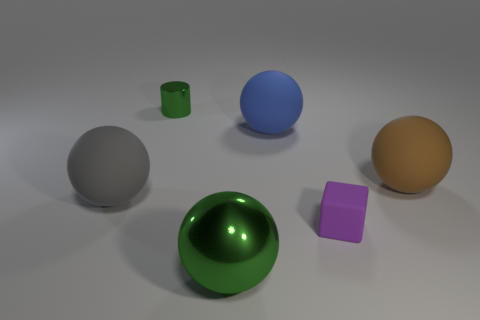Subtract all big rubber balls. How many balls are left? 1 Subtract all blue balls. How many balls are left? 3 Subtract 1 spheres. How many spheres are left? 3 Add 4 large metal things. How many objects exist? 10 Subtract all blocks. How many objects are left? 5 Subtract all purple spheres. Subtract all red cylinders. How many spheres are left? 4 Subtract all brown cylinders. How many brown spheres are left? 1 Subtract all blue rubber things. Subtract all green cylinders. How many objects are left? 4 Add 6 large brown rubber objects. How many large brown rubber objects are left? 7 Add 1 rubber balls. How many rubber balls exist? 4 